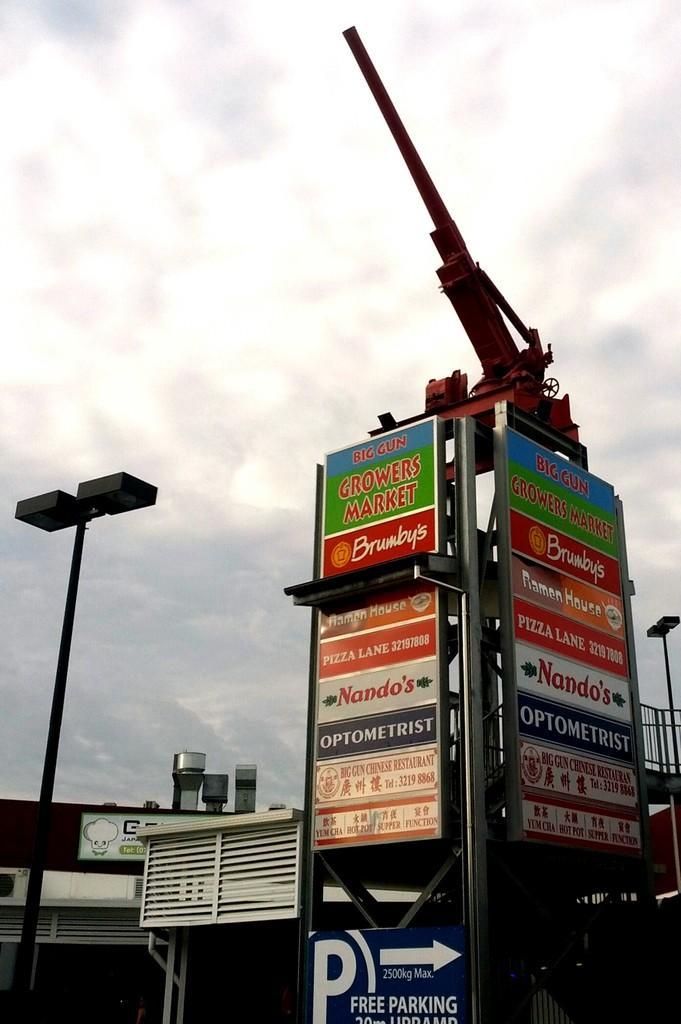Describe this image in one or two sentences. In this image there are so many buildings, in which we can see there is a pole with some boards around and canon on the top. 